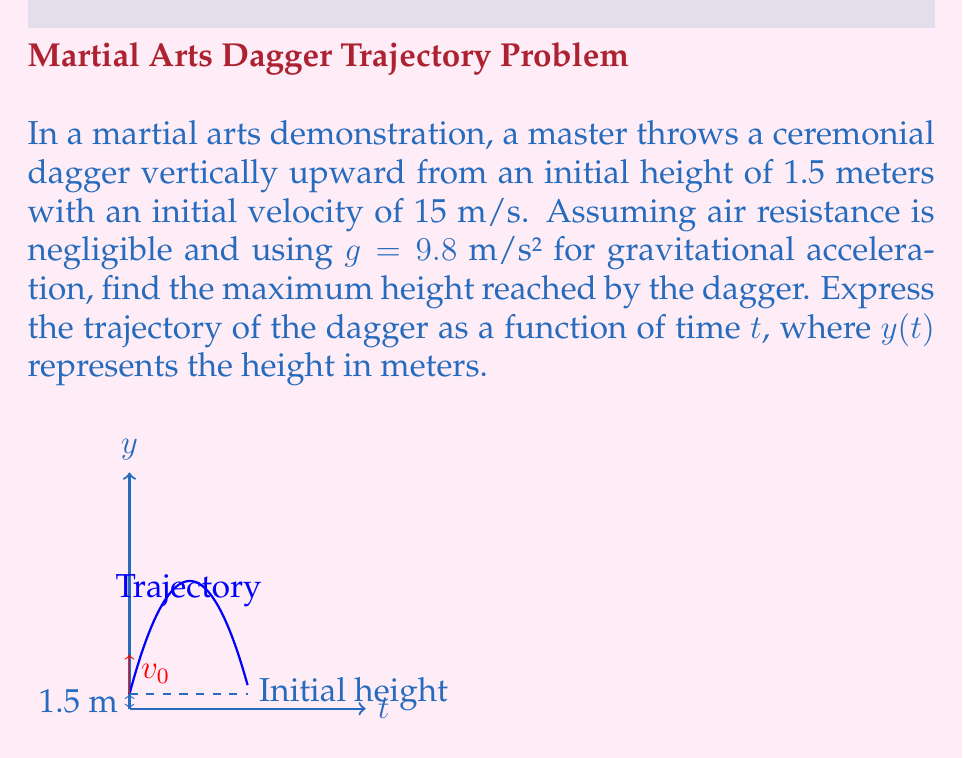Could you help me with this problem? To solve this problem, we'll use the first-order differential equation for the motion of an object under constant acceleration:

$$\frac{d^2y}{dt^2} = -g$$

Where y is the height and g is the gravitational acceleration.

Step 1: Integrate the equation once to get the velocity function:
$$\frac{dy}{dt} = -gt + v_0$$
Where $v_0$ is the initial velocity (15 m/s).

Step 2: Integrate again to get the position function:
$$y(t) = -\frac{1}{2}gt^2 + v_0t + y_0$$
Where $y_0$ is the initial height (1.5 m).

Substituting the values:
$$y(t) = -4.9t^2 + 15t + 1.5$$

Step 3: To find the maximum height, we need to find when the velocity is zero:
$$\frac{dy}{dt} = -9.8t + 15 = 0$$
$$t = \frac{15}{9.8} \approx 1.53\text{ seconds}$$

Step 4: Substitute this time back into the position function:
$$y_{max} = -4.9(1.53)^2 + 15(1.53) + 1.5 \approx 13\text{ meters}$$

Therefore, the maximum height reached is approximately 13 meters.
Answer: $y(t) = -4.9t^2 + 15t + 1.5$; Max height ≈ 13 m 